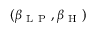Convert formula to latex. <formula><loc_0><loc_0><loc_500><loc_500>( \beta _ { L P } , \beta _ { H } )</formula> 